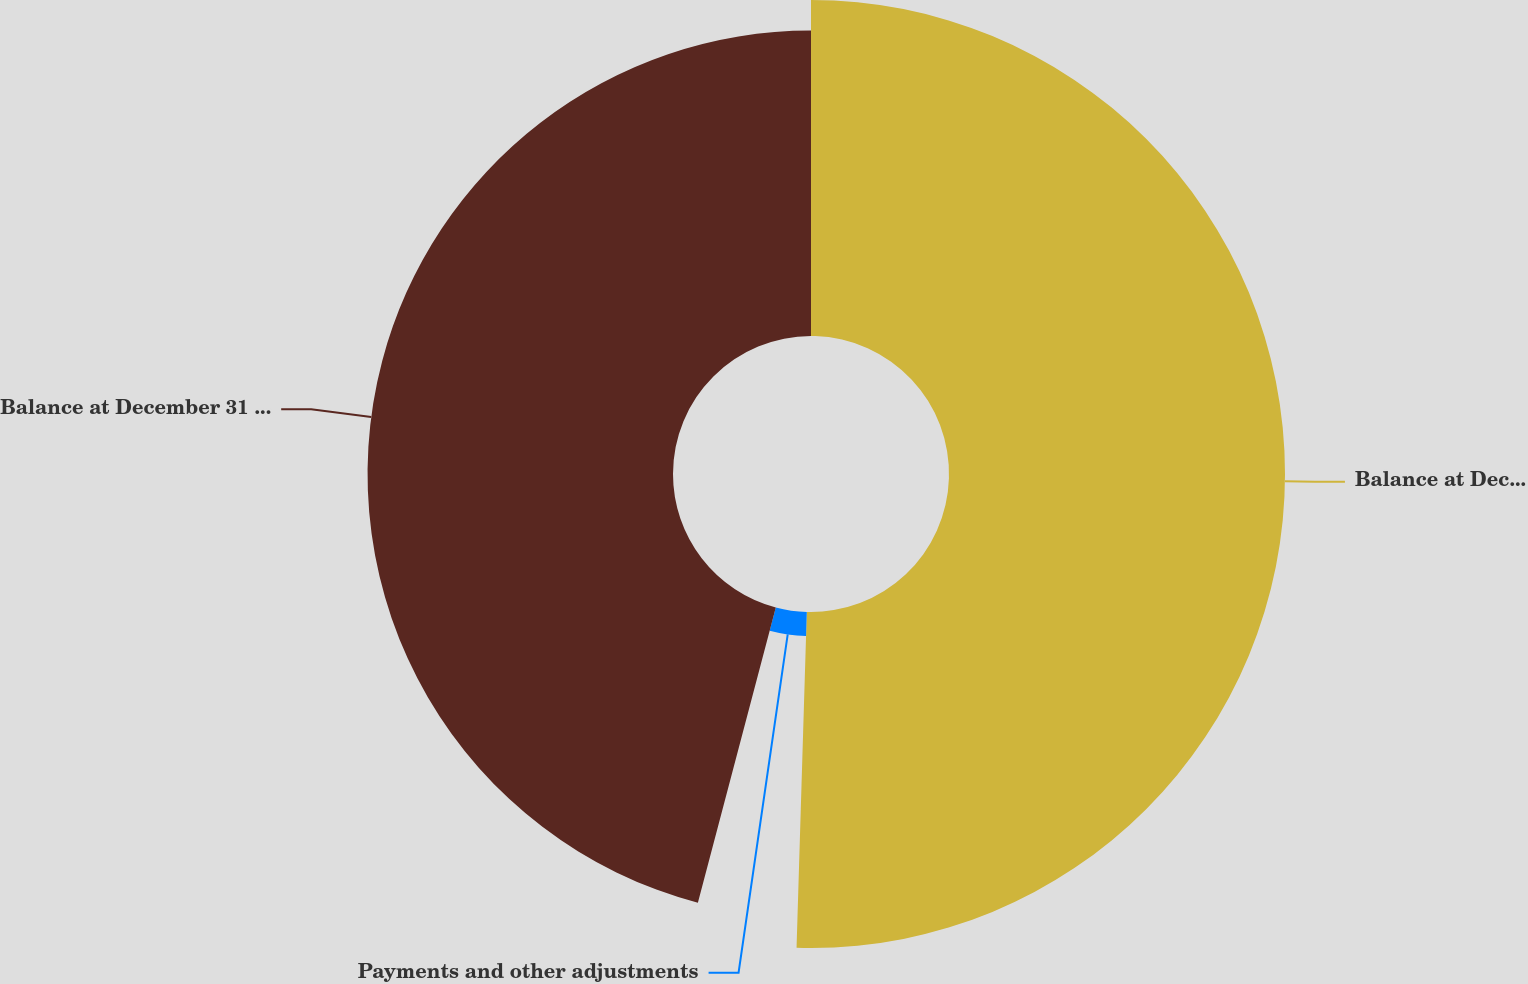Convert chart to OTSL. <chart><loc_0><loc_0><loc_500><loc_500><pie_chart><fcel>Balance at December 31 2008<fcel>Payments and other adjustments<fcel>Balance at December 31 2009<nl><fcel>50.48%<fcel>3.62%<fcel>45.89%<nl></chart> 